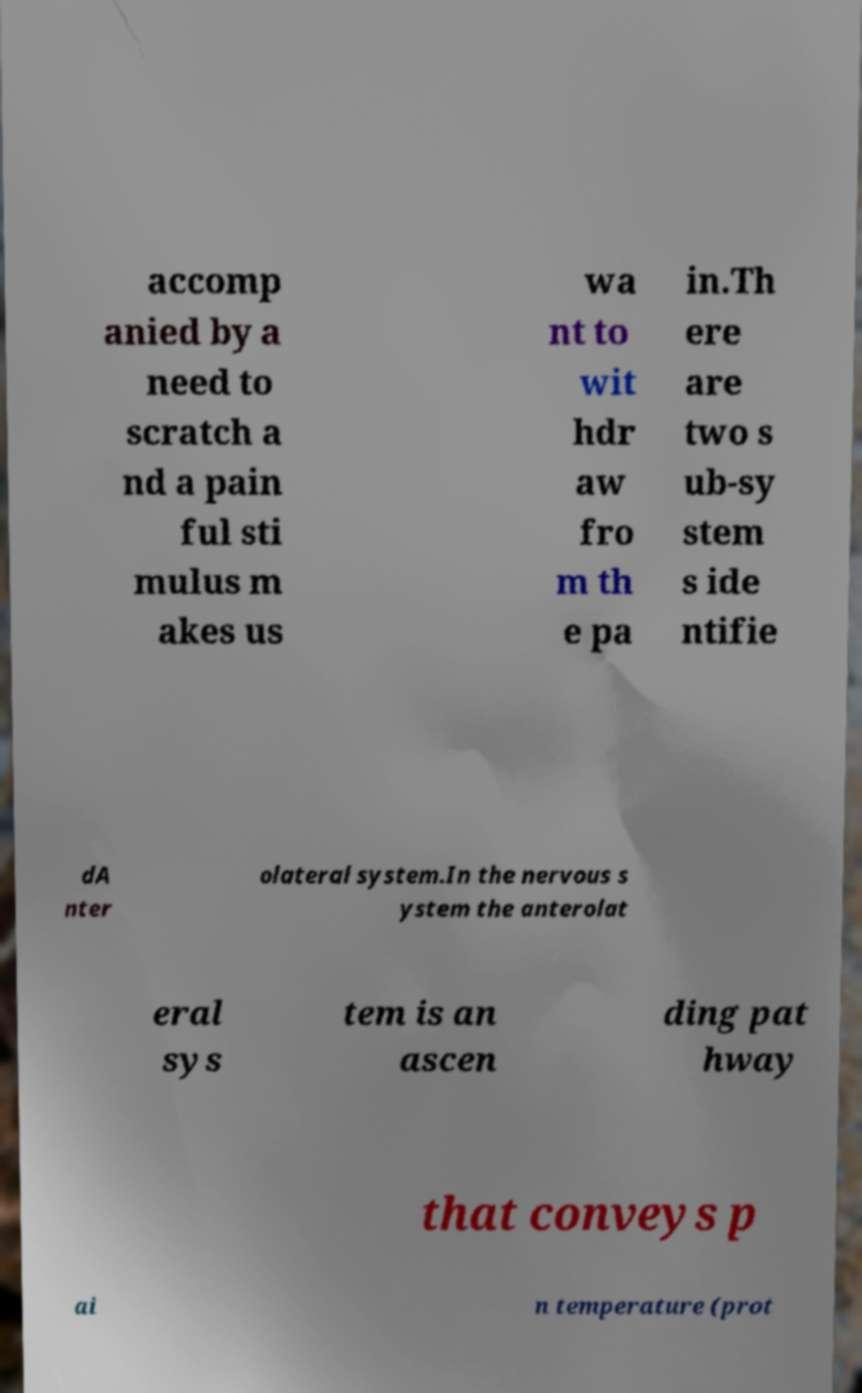What messages or text are displayed in this image? I need them in a readable, typed format. accomp anied by a need to scratch a nd a pain ful sti mulus m akes us wa nt to wit hdr aw fro m th e pa in.Th ere are two s ub-sy stem s ide ntifie dA nter olateral system.In the nervous s ystem the anterolat eral sys tem is an ascen ding pat hway that conveys p ai n temperature (prot 